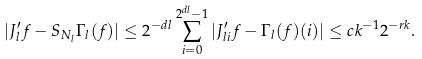<formula> <loc_0><loc_0><loc_500><loc_500>| J ^ { \prime } _ { l } f - S _ { N _ { l } } \Gamma _ { l } ( f ) | \leq 2 ^ { - d l } \sum _ { i = 0 } ^ { 2 ^ { d l } - 1 } | J ^ { \prime } _ { l i } f - \Gamma _ { l } ( f ) ( i ) | \leq c k ^ { - 1 } 2 ^ { - r k } .</formula> 